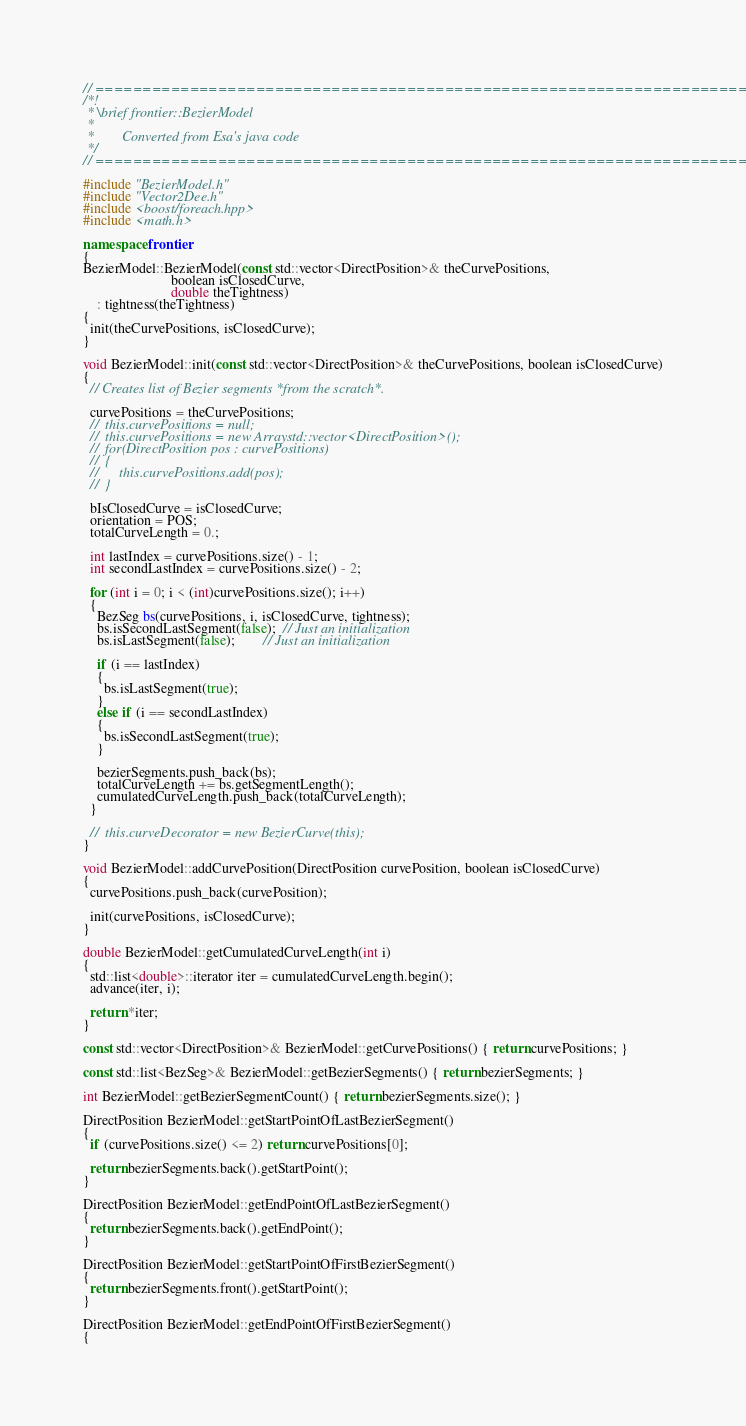Convert code to text. <code><loc_0><loc_0><loc_500><loc_500><_C++_>// ======================================================================
/*!
 * \brief frontier::BezierModel
 *
 *		  Converted from Esa's java code
 */
// ======================================================================

#include "BezierModel.h"
#include "Vector2Dee.h"
#include <boost/foreach.hpp>
#include <math.h>

namespace frontier
{
BezierModel::BezierModel(const std::vector<DirectPosition>& theCurvePositions,
                         boolean isClosedCurve,
                         double theTightness)
    : tightness(theTightness)
{
  init(theCurvePositions, isClosedCurve);
}

void BezierModel::init(const std::vector<DirectPosition>& theCurvePositions, boolean isClosedCurve)
{
  // Creates list of Bezier segments *from the scratch*.

  curvePositions = theCurvePositions;
  //	this.curvePositions = null;
  //	this.curvePositions = new Arraystd::vector<DirectPosition>();
  //	for(DirectPosition pos : curvePositions)
  //	{
  //		this.curvePositions.add(pos);
  //	}

  bIsClosedCurve = isClosedCurve;
  orientation = POS;
  totalCurveLength = 0.;

  int lastIndex = curvePositions.size() - 1;
  int secondLastIndex = curvePositions.size() - 2;

  for (int i = 0; i < (int)curvePositions.size(); i++)
  {
    BezSeg bs(curvePositions, i, isClosedCurve, tightness);
    bs.isSecondLastSegment(false);  // Just an initialization
    bs.isLastSegment(false);        // Just an initialization

    if (i == lastIndex)
    {
      bs.isLastSegment(true);
    }
    else if (i == secondLastIndex)
    {
      bs.isSecondLastSegment(true);
    }

    bezierSegments.push_back(bs);
    totalCurveLength += bs.getSegmentLength();
    cumulatedCurveLength.push_back(totalCurveLength);
  }

  //	this.curveDecorator = new BezierCurve(this);
}

void BezierModel::addCurvePosition(DirectPosition curvePosition, boolean isClosedCurve)
{
  curvePositions.push_back(curvePosition);

  init(curvePositions, isClosedCurve);
}

double BezierModel::getCumulatedCurveLength(int i)
{
  std::list<double>::iterator iter = cumulatedCurveLength.begin();
  advance(iter, i);

  return *iter;
}

const std::vector<DirectPosition>& BezierModel::getCurvePositions() { return curvePositions; }

const std::list<BezSeg>& BezierModel::getBezierSegments() { return bezierSegments; }

int BezierModel::getBezierSegmentCount() { return bezierSegments.size(); }

DirectPosition BezierModel::getStartPointOfLastBezierSegment()
{
  if (curvePositions.size() <= 2) return curvePositions[0];

  return bezierSegments.back().getStartPoint();
}

DirectPosition BezierModel::getEndPointOfLastBezierSegment()
{
  return bezierSegments.back().getEndPoint();
}

DirectPosition BezierModel::getStartPointOfFirstBezierSegment()
{
  return bezierSegments.front().getStartPoint();
}

DirectPosition BezierModel::getEndPointOfFirstBezierSegment()
{</code> 